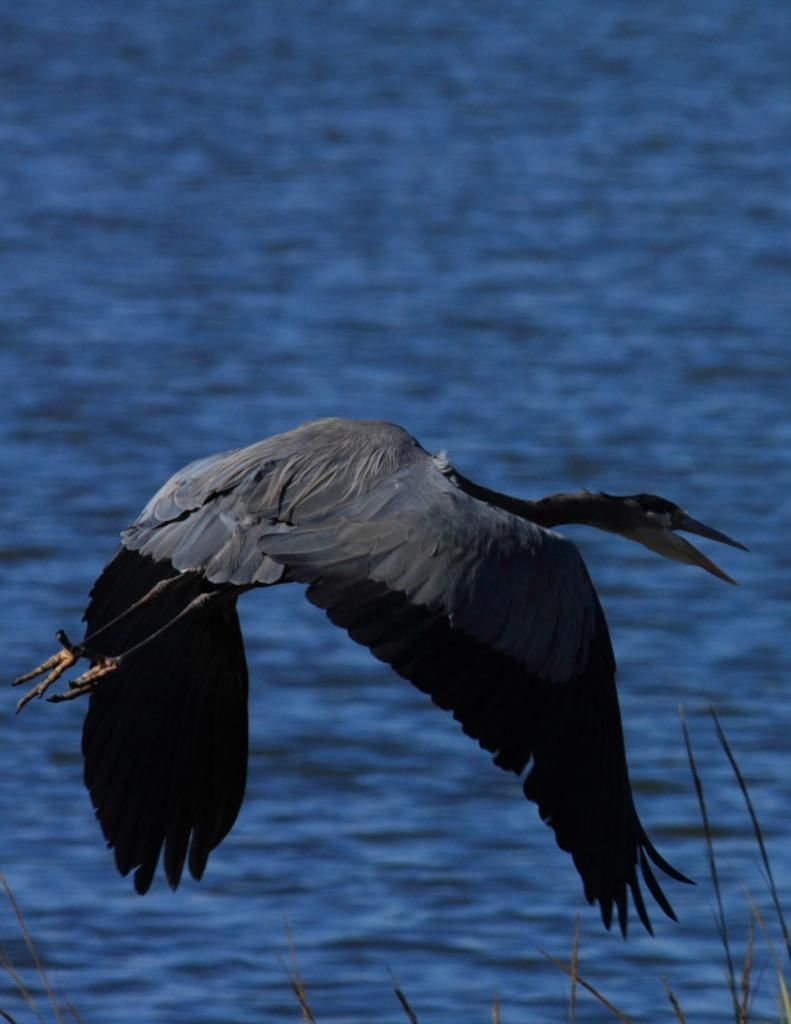What type of animal can be seen in the image? There is a bird in the image. What is the bird doing in the image? The bird is flying. What color is the bird in the image? The bird is black in color. What can be seen in the background of the image? There is a water body in the background of the image. Does the bird have a horn in the image? No, there is no horn present on the bird in the image. Can you see a rat in the image? No, there is no rat present in the image; it features a black bird flying near a water body. 